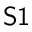Convert formula to latex. <formula><loc_0><loc_0><loc_500><loc_500>S 1</formula> 